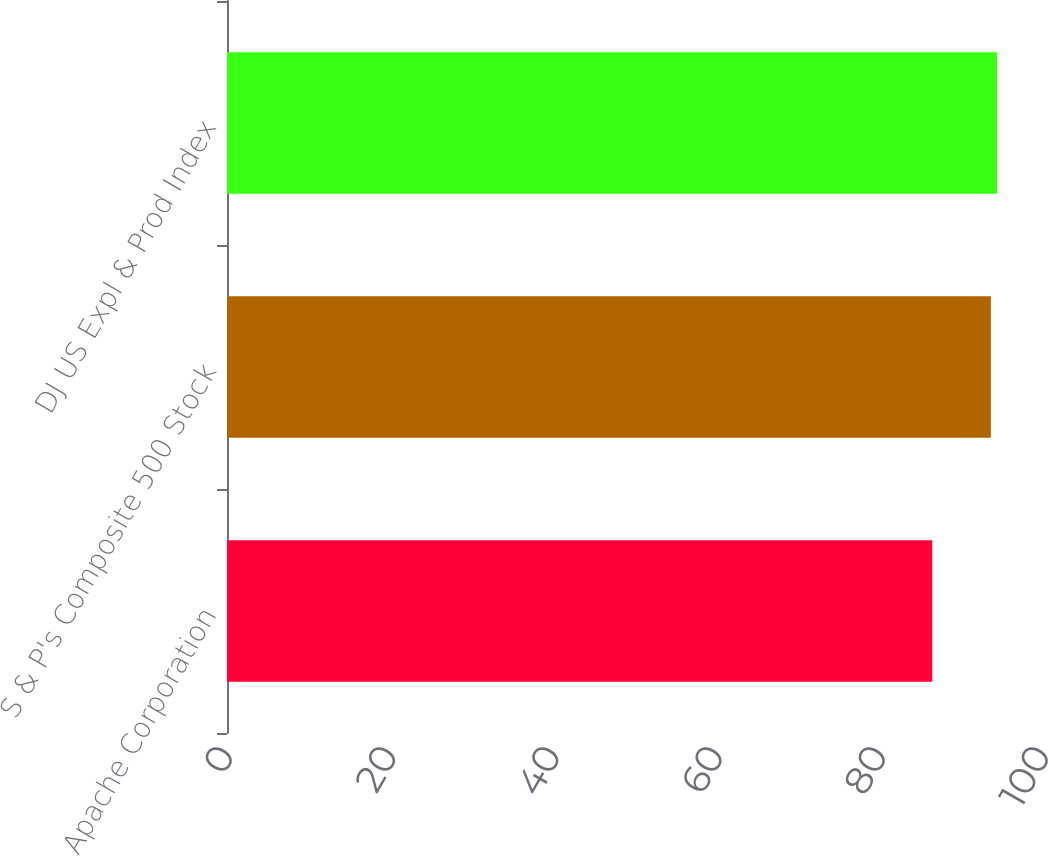Convert chart. <chart><loc_0><loc_0><loc_500><loc_500><bar_chart><fcel>Apache Corporation<fcel>S & P's Composite 500 Stock<fcel>DJ US Expl & Prod Index<nl><fcel>86.43<fcel>93.61<fcel>94.38<nl></chart> 